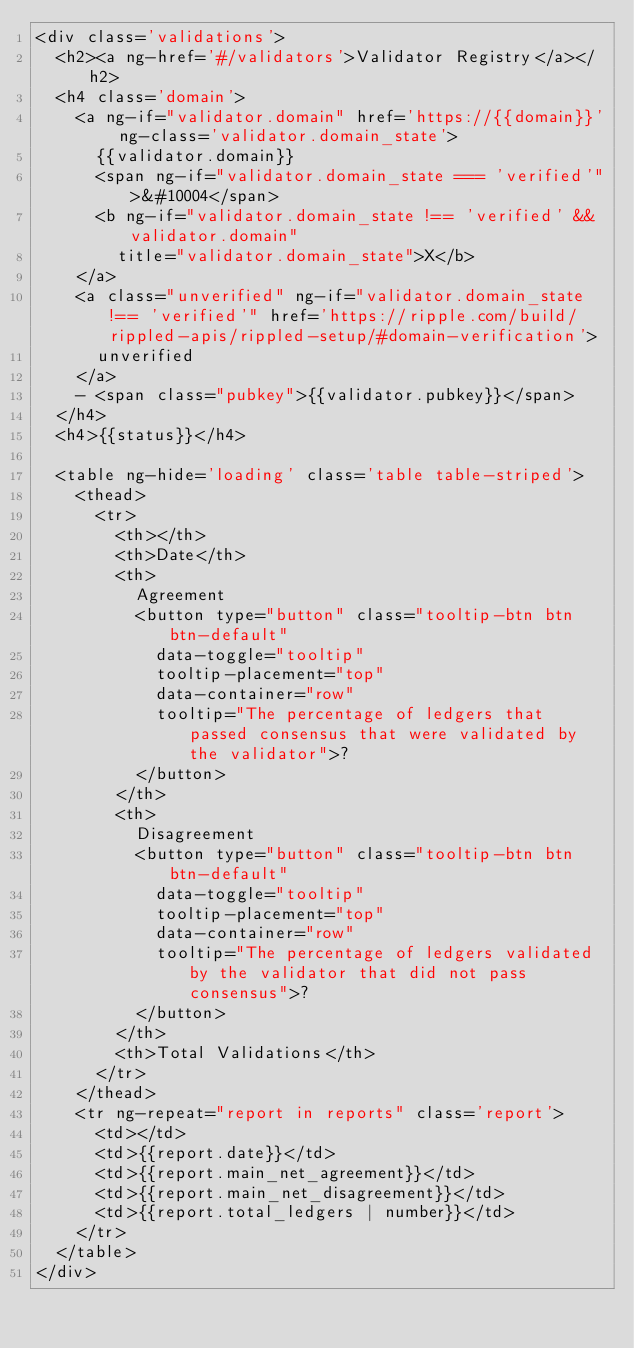<code> <loc_0><loc_0><loc_500><loc_500><_HTML_><div class='validations'>
  <h2><a ng-href='#/validators'>Validator Registry</a></h2>
  <h4 class='domain'>
    <a ng-if="validator.domain" href='https://{{domain}}' ng-class='validator.domain_state'>
      {{validator.domain}}
      <span ng-if="validator.domain_state === 'verified'">&#10004</span>
      <b ng-if="validator.domain_state !== 'verified' && validator.domain"
        title="validator.domain_state">X</b>
    </a>
    <a class="unverified" ng-if="validator.domain_state !== 'verified'" href='https://ripple.com/build/rippled-apis/rippled-setup/#domain-verification'>
      unverified
    </a>
    - <span class="pubkey">{{validator.pubkey}}</span>
  </h4>
  <h4>{{status}}</h4>

  <table ng-hide='loading' class='table table-striped'>
    <thead>
      <tr>
        <th></th>
        <th>Date</th>
        <th>
          Agreement
          <button type="button" class="tooltip-btn btn btn-default"
            data-toggle="tooltip"
            tooltip-placement="top"
            data-container="row"
            tooltip="The percentage of ledgers that passed consensus that were validated by the validator">?
          </button>
        </th>
        <th>
          Disagreement
          <button type="button" class="tooltip-btn btn btn-default"
            data-toggle="tooltip"
            tooltip-placement="top"
            data-container="row"
            tooltip="The percentage of ledgers validated by the validator that did not pass consensus">?
          </button>
        </th>
        <th>Total Validations</th>
      </tr>
    </thead>
    <tr ng-repeat="report in reports" class='report'>
      <td></td>
      <td>{{report.date}}</td>
      <td>{{report.main_net_agreement}}</td>
      <td>{{report.main_net_disagreement}}</td>
      <td>{{report.total_ledgers | number}}</td>
    </tr>
  </table>
</div>
</code> 